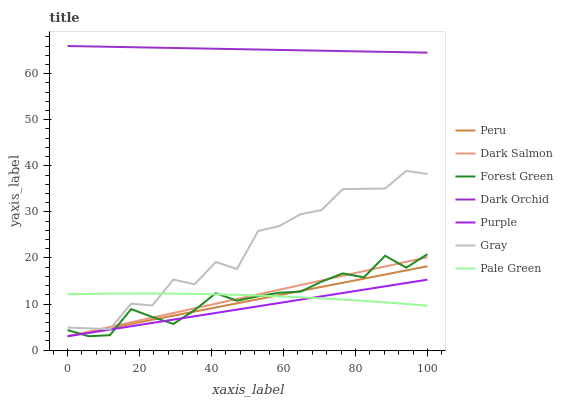Does Dark Salmon have the minimum area under the curve?
Answer yes or no. No. Does Dark Salmon have the maximum area under the curve?
Answer yes or no. No. Is Purple the smoothest?
Answer yes or no. No. Is Purple the roughest?
Answer yes or no. No. Does Dark Orchid have the lowest value?
Answer yes or no. No. Does Purple have the highest value?
Answer yes or no. No. Is Pale Green less than Dark Orchid?
Answer yes or no. Yes. Is Dark Orchid greater than Dark Salmon?
Answer yes or no. Yes. Does Pale Green intersect Dark Orchid?
Answer yes or no. No. 